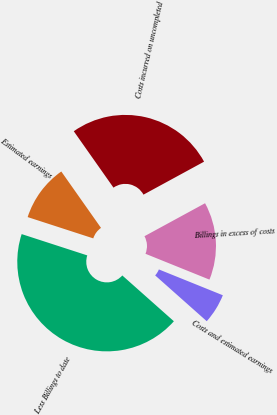<chart> <loc_0><loc_0><loc_500><loc_500><pie_chart><fcel>Costs incurred on uncompleted<fcel>Estimated earnings<fcel>Less Billings to date<fcel>Costs and estimated earnings<fcel>Billings in excess of costs<nl><fcel>26.83%<fcel>10.24%<fcel>43.44%<fcel>5.45%<fcel>14.04%<nl></chart> 